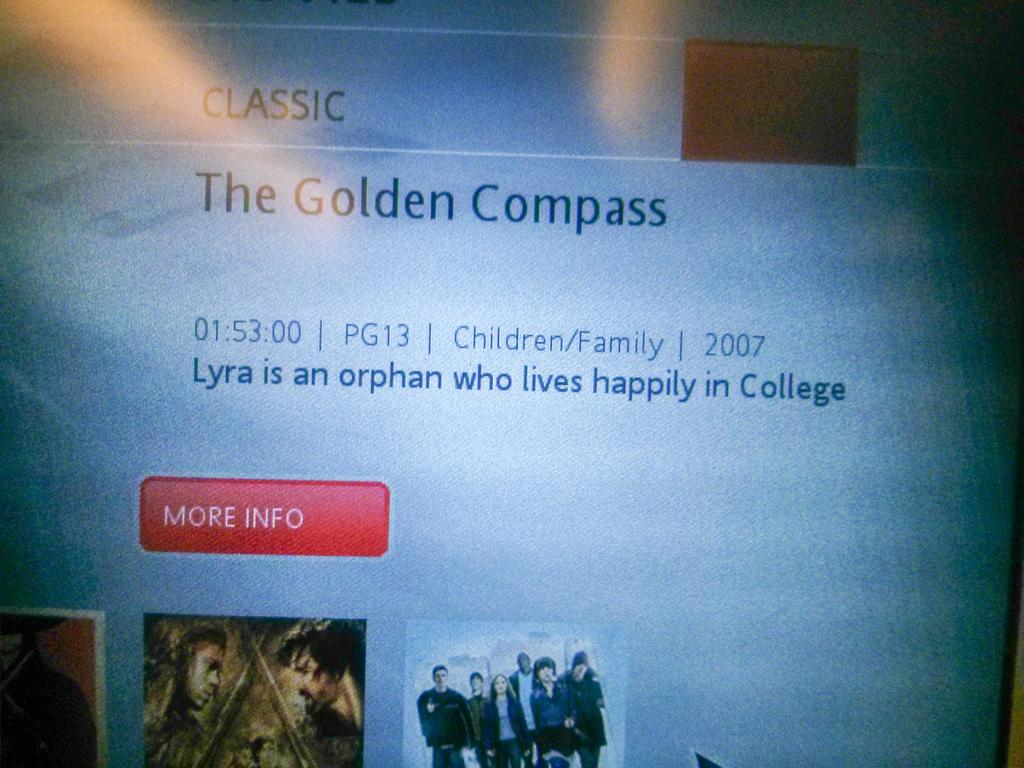What is the main object in the image? There is a screen in the image. What can be seen on the screen? There is text and pictures on the screen. What type of range is visible in the image? There is no range present in the image; it features a screen with text and pictures. What color is the button on the screen? There is no button present on the screen; it only displays text and pictures. 